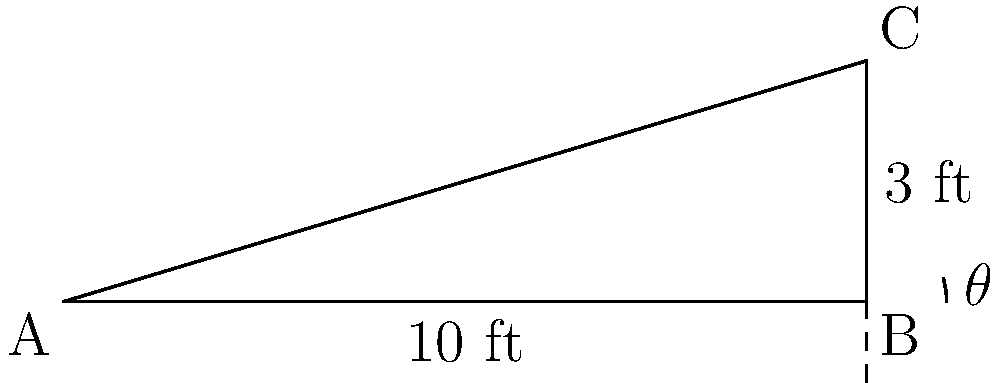As a homebuyer in New York City, you're considering a property with a sloped roof. The roof spans 10 feet horizontally and rises 3 feet vertically. What is the angle $\theta$ of the roof slope, rounded to the nearest degree? (Hint: This angle is crucial for ensuring proper water drainage.) To find the angle of the roof slope, we can use the arctangent function. Here's how:

1) In a right triangle, tangent of an angle is the ratio of the opposite side to the adjacent side.

2) In this case:
   - The rise (opposite side) is 3 feet
   - The run (adjacent side) is 10 feet

3) So, $\tan(\theta) = \frac{\text{rise}}{\text{run}} = \frac{3}{10} = 0.3$

4) To find $\theta$, we take the arctangent (inverse tangent) of this ratio:

   $\theta = \arctan(0.3)$

5) Using a calculator or computer:

   $\theta \approx 16.70^\circ$

6) Rounding to the nearest degree:

   $\theta \approx 17^\circ$

This 17-degree slope is typically sufficient for proper water drainage in most residential roofs, which is an important consideration for a homebuyer in a rainy city like New York.
Answer: $17^\circ$ 